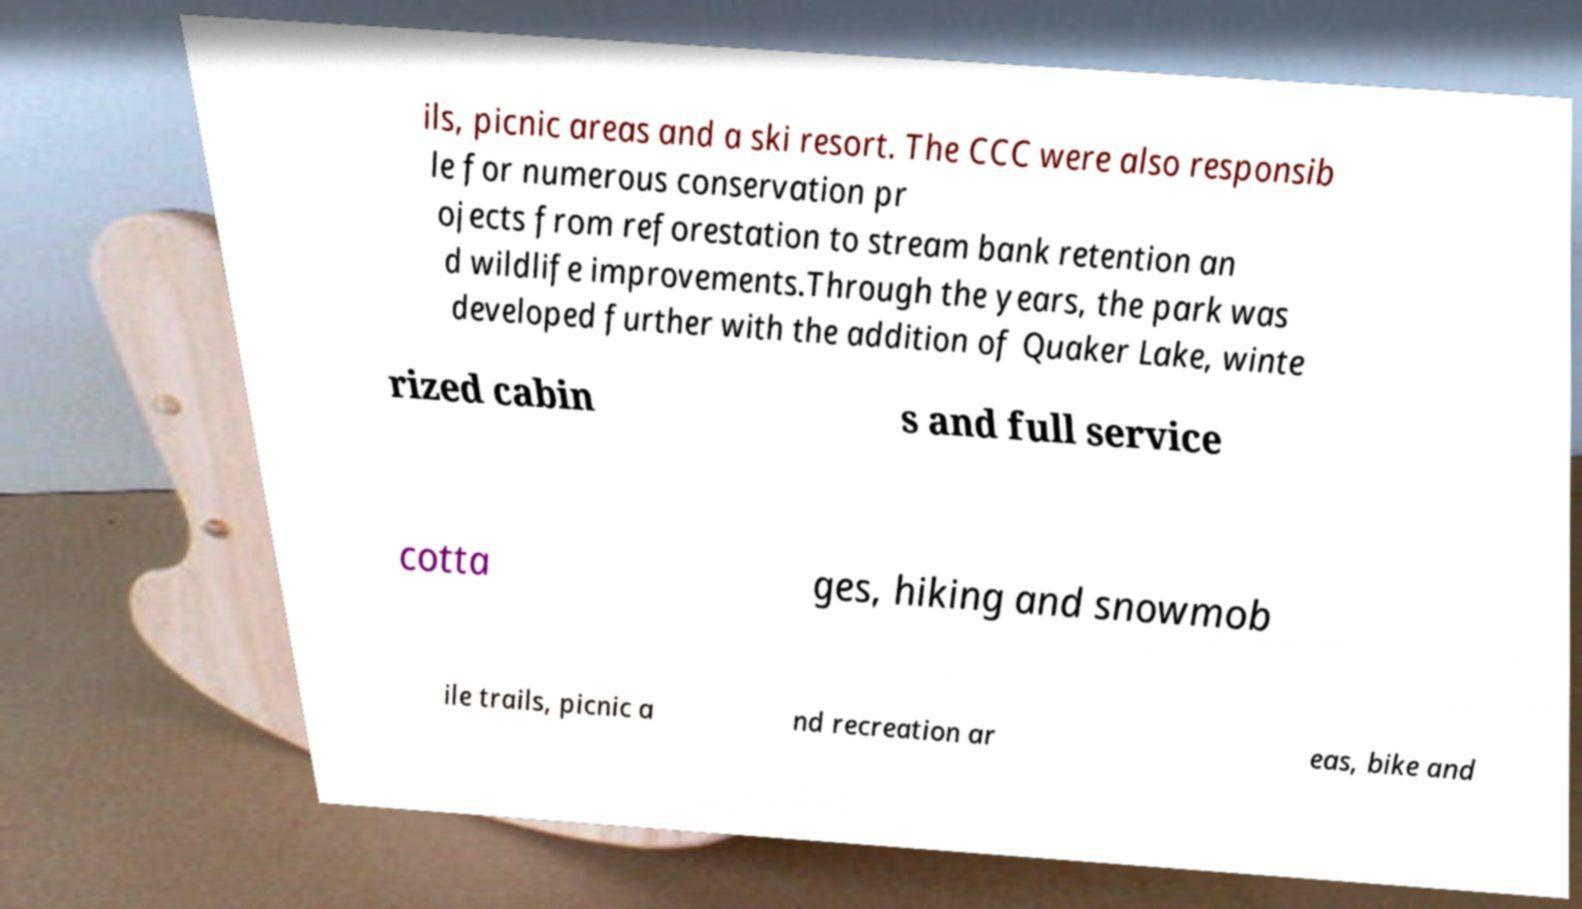What messages or text are displayed in this image? I need them in a readable, typed format. ils, picnic areas and a ski resort. The CCC were also responsib le for numerous conservation pr ojects from reforestation to stream bank retention an d wildlife improvements.Through the years, the park was developed further with the addition of Quaker Lake, winte rized cabin s and full service cotta ges, hiking and snowmob ile trails, picnic a nd recreation ar eas, bike and 